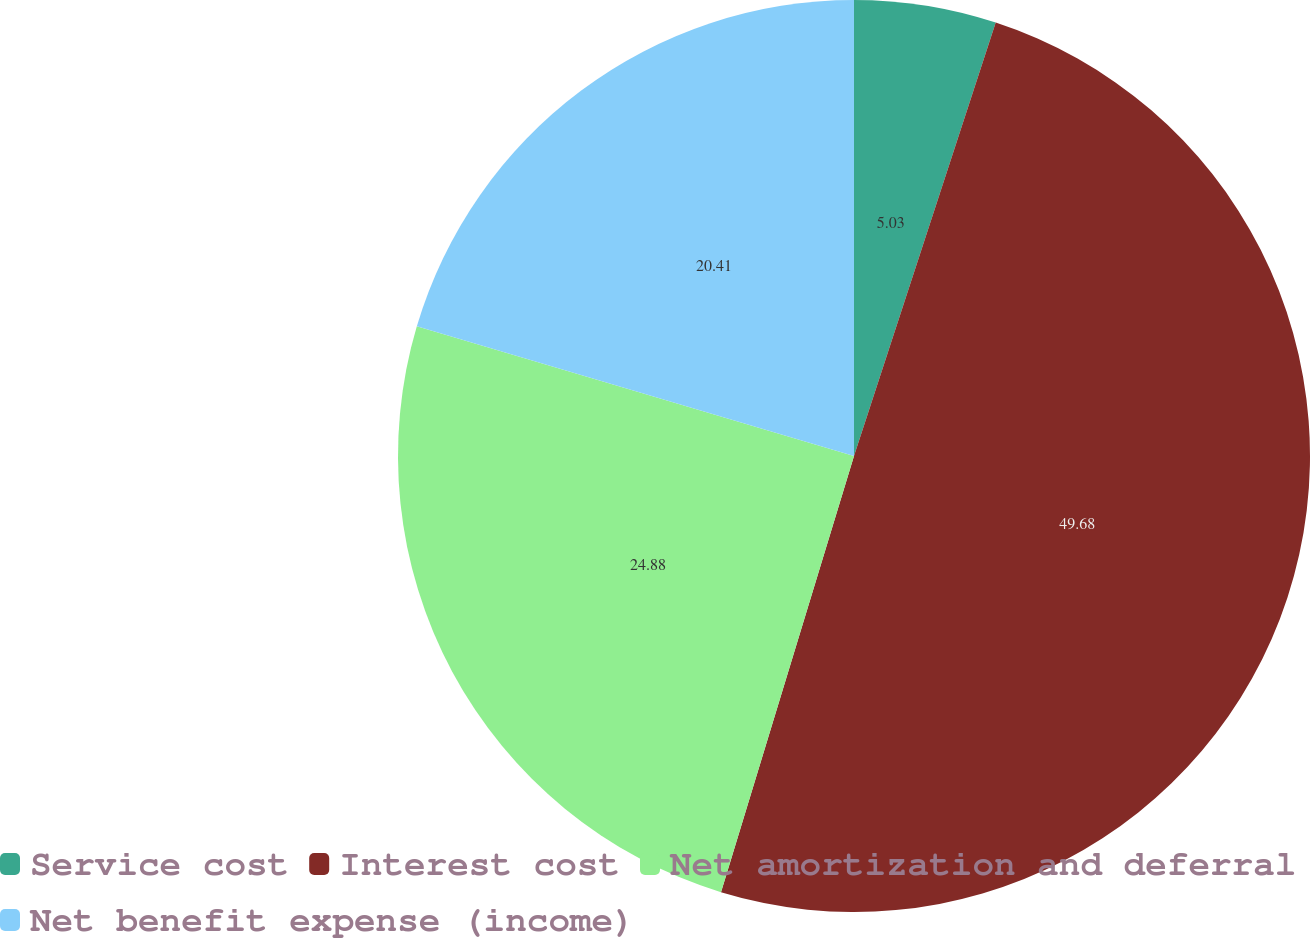Convert chart to OTSL. <chart><loc_0><loc_0><loc_500><loc_500><pie_chart><fcel>Service cost<fcel>Interest cost<fcel>Net amortization and deferral<fcel>Net benefit expense (income)<nl><fcel>5.03%<fcel>49.68%<fcel>24.88%<fcel>20.41%<nl></chart> 